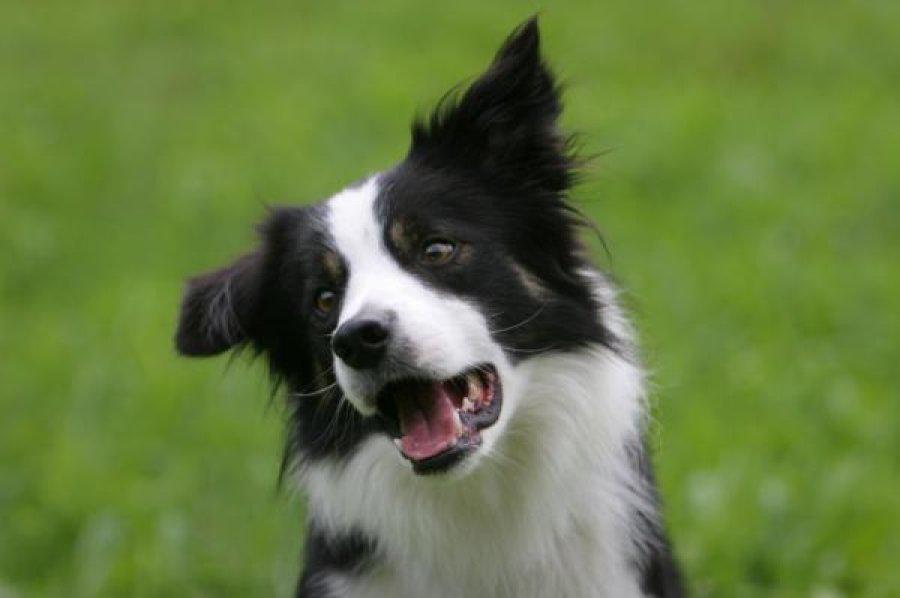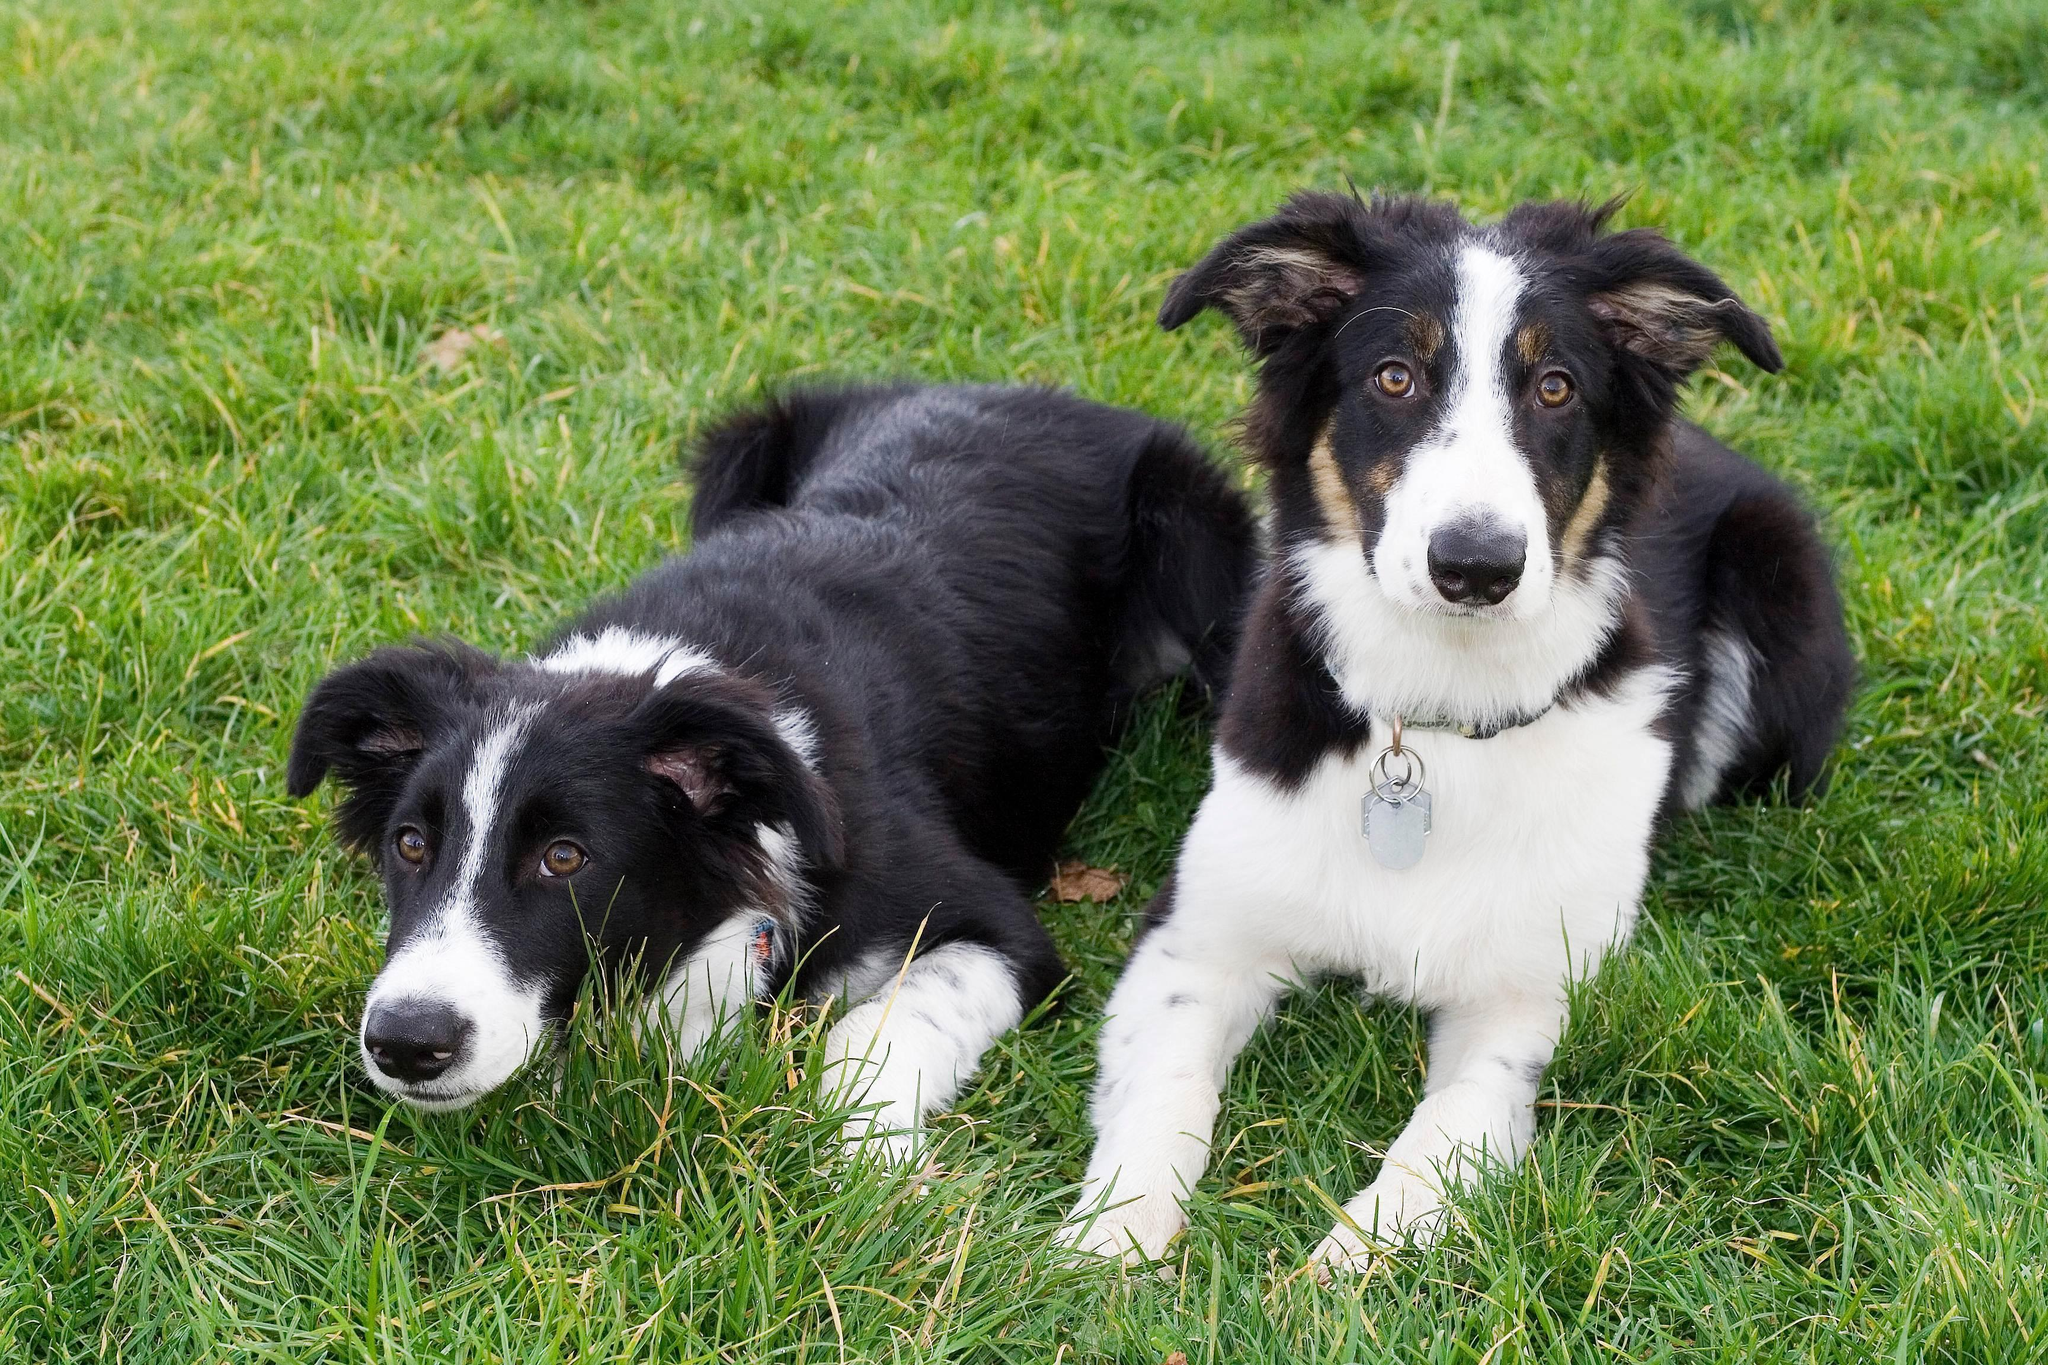The first image is the image on the left, the second image is the image on the right. Analyze the images presented: Is the assertion "There are at least four dogs in total." valid? Answer yes or no. No. The first image is the image on the left, the second image is the image on the right. Evaluate the accuracy of this statement regarding the images: "in the left image there is a do with the left ear up and the right ear down". Is it true? Answer yes or no. No. 